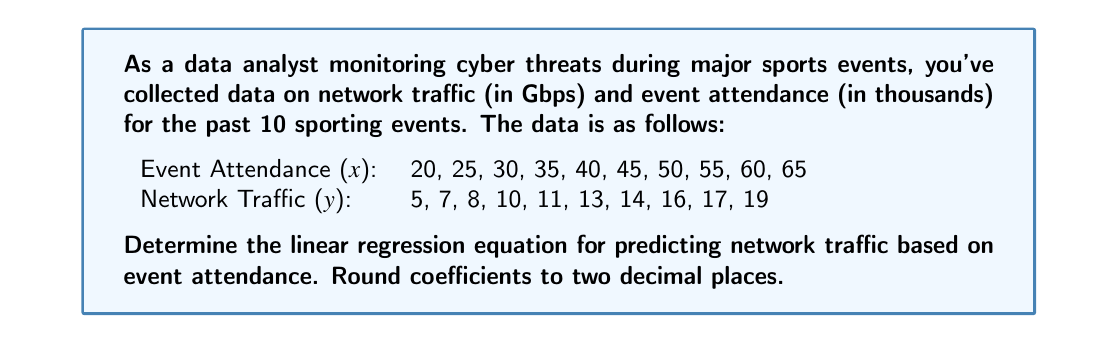Can you answer this question? To find the linear regression equation, we need to calculate the slope (m) and y-intercept (b) of the line of best fit. We'll use the following formulas:

1. Slope (m): $m = \frac{n\sum xy - \sum x \sum y}{n\sum x^2 - (\sum x)^2}$
2. Y-intercept (b): $b = \bar{y} - m\bar{x}$

Where n is the number of data points, $\bar{x}$ is the mean of x values, and $\bar{y}$ is the mean of y values.

Step 1: Calculate the required sums and means:
n = 10
$\sum x = 425$
$\sum y = 120$
$\sum xy = 5,525$
$\sum x^2 = 19,375$
$\bar{x} = 42.5$
$\bar{y} = 12$

Step 2: Calculate the slope (m):
$m = \frac{10(5,525) - 425(120)}{10(19,375) - 425^2}$
$m = \frac{55,250 - 51,000}{193,750 - 180,625}$
$m = \frac{4,250}{13,125} = 0.3238$

Rounded to two decimal places: $m = 0.32$

Step 3: Calculate the y-intercept (b):
$b = 12 - 0.32(42.5) = -1.6$

Step 4: Form the linear regression equation:
$y = mx + b$
$y = 0.32x - 1.6$

Where y is the predicted network traffic (in Gbps) and x is the event attendance (in thousands).
Answer: The linear regression equation for predicting network traffic based on event attendance is:

$y = 0.32x - 1.6$

Where y is the predicted network traffic (in Gbps) and x is the event attendance (in thousands). 